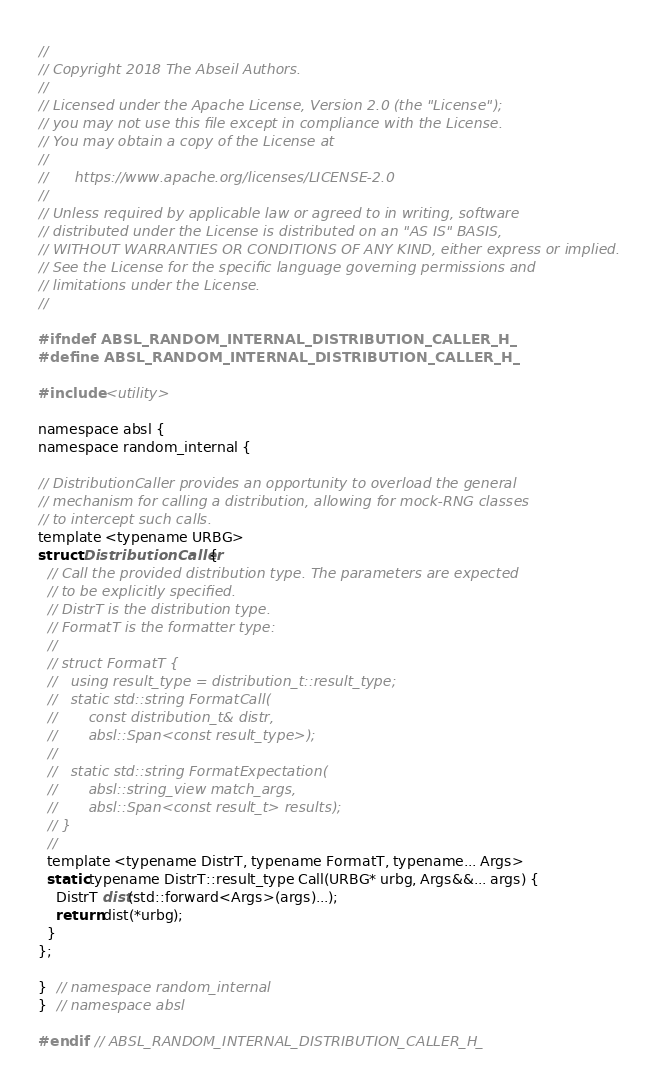<code> <loc_0><loc_0><loc_500><loc_500><_C_>//
// Copyright 2018 The Abseil Authors.
//
// Licensed under the Apache License, Version 2.0 (the "License");
// you may not use this file except in compliance with the License.
// You may obtain a copy of the License at
//
//      https://www.apache.org/licenses/LICENSE-2.0
//
// Unless required by applicable law or agreed to in writing, software
// distributed under the License is distributed on an "AS IS" BASIS,
// WITHOUT WARRANTIES OR CONDITIONS OF ANY KIND, either express or implied.
// See the License for the specific language governing permissions and
// limitations under the License.
//

#ifndef ABSL_RANDOM_INTERNAL_DISTRIBUTION_CALLER_H_
#define ABSL_RANDOM_INTERNAL_DISTRIBUTION_CALLER_H_

#include <utility>

namespace absl {
namespace random_internal {

// DistributionCaller provides an opportunity to overload the general
// mechanism for calling a distribution, allowing for mock-RNG classes
// to intercept such calls.
template <typename URBG>
struct DistributionCaller {
  // Call the provided distribution type. The parameters are expected
  // to be explicitly specified.
  // DistrT is the distribution type.
  // FormatT is the formatter type:
  //
  // struct FormatT {
  //   using result_type = distribution_t::result_type;
  //   static std::string FormatCall(
  //       const distribution_t& distr,
  //       absl::Span<const result_type>);
  //
  //   static std::string FormatExpectation(
  //       absl::string_view match_args,
  //       absl::Span<const result_t> results);
  // }
  //
  template <typename DistrT, typename FormatT, typename... Args>
  static typename DistrT::result_type Call(URBG* urbg, Args&&... args) {
    DistrT dist(std::forward<Args>(args)...);
    return dist(*urbg);
  }
};

}  // namespace random_internal
}  // namespace absl

#endif  // ABSL_RANDOM_INTERNAL_DISTRIBUTION_CALLER_H_
</code> 